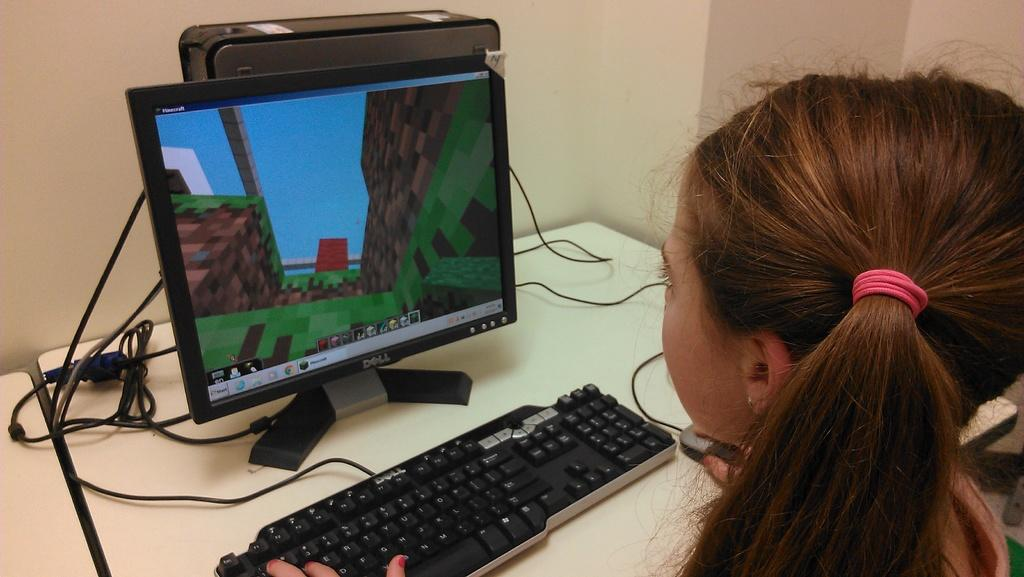<image>
Relay a brief, clear account of the picture shown. A girl is looking at a Dell computer monitor. 